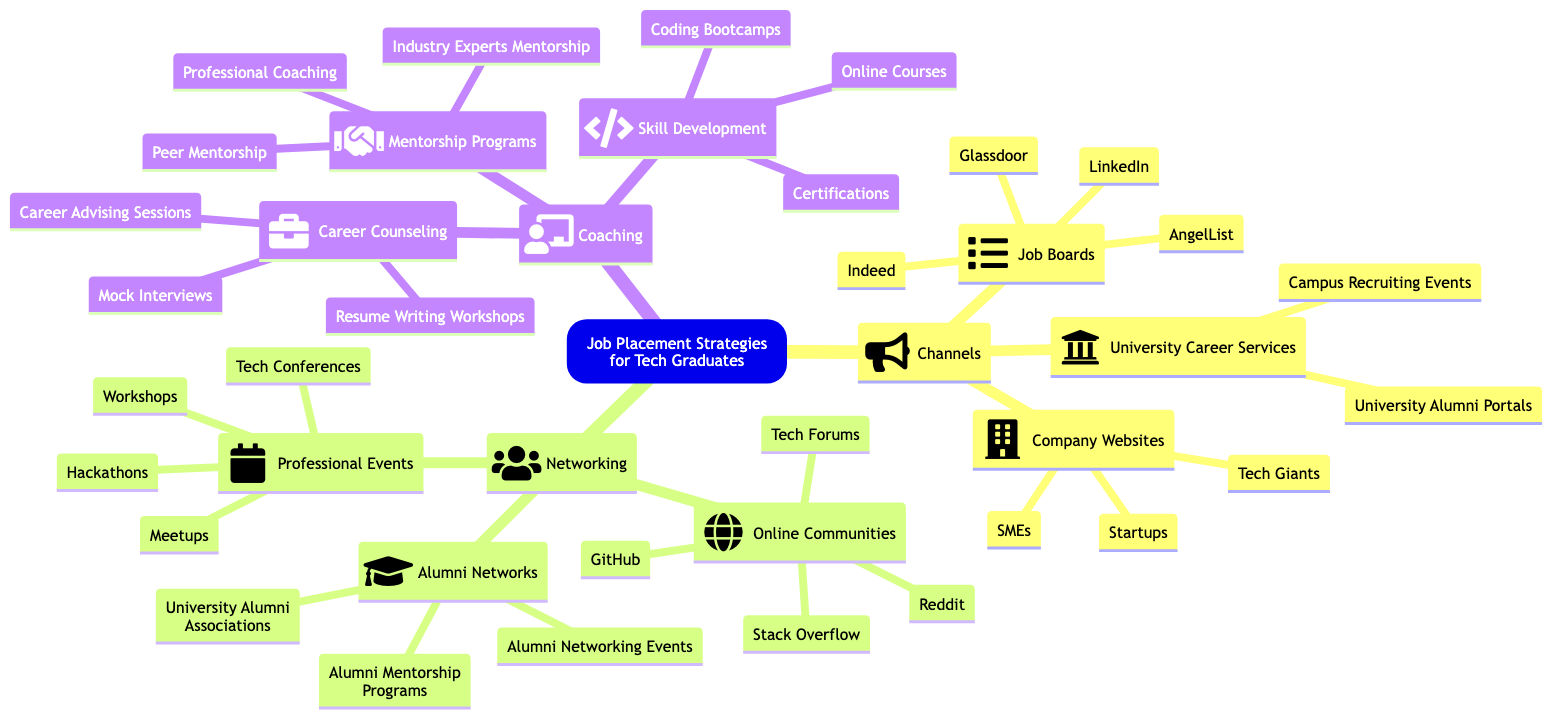What are the three main categories of job placement strategies for tech graduates? The diagram presents three main categories listed under 'Job Placement Strategies for Tech Graduates': Channels, Networking, and Coaching.
Answer: Channels, Networking, Coaching How many job boards are mentioned in the diagram? The section under 'Channels' lists four job boards: LinkedIn, Indeed, Glassdoor, and AngelList. Counting these gives us a total of four job boards.
Answer: 4 Which channel includes Campus Recruiting Events? 'Campus Recruiting Events' is one of the offerings listed under 'University Career Services', which is a subcategory within 'Channels'. The relationship is found by tracing back to the 'Channels' category.
Answer: University Career Services Name one online community mentioned in the diagram. Looking under 'Networking', specifically within the 'Online Communities' category, the diagram lists GitHub, Stack Overflow, Reddit, and Tech Forums. GitHub is one of these specified communities.
Answer: GitHub Which subcategory has the most items in the diagram? By reviewing each subcategory, 'Coaching' has three main areas: Career Counseling (3 items), Skill Development (3 items), and Mentorship Programs (3 items). However, they all contain the same number of items, making this question slightly tricky as it requires synthesizing the information.
Answer: Career Counseling, Skill Development, Mentorship Programs How many types of professional events are listed? Under 'Networking', there is a section labeled 'Professional Events' that includes Tech Conferences, Hackathons, Meetups, and Workshops. Counting these types gives us four distinct events.
Answer: 4 What type of development is associated with Coding Bootcamps? Coding Bootcamps are listed under the 'Skill Development' section of 'Coaching'. This section includes various forms of skill enhancement programs.
Answer: Skill Development What is one type of career counseling offered? Looking into the 'Career Counseling' section under 'Coaching', we can see that 'Mock Interviews' is mentioned as one available service, providing practical assistance for students.
Answer: Mock Interviews 